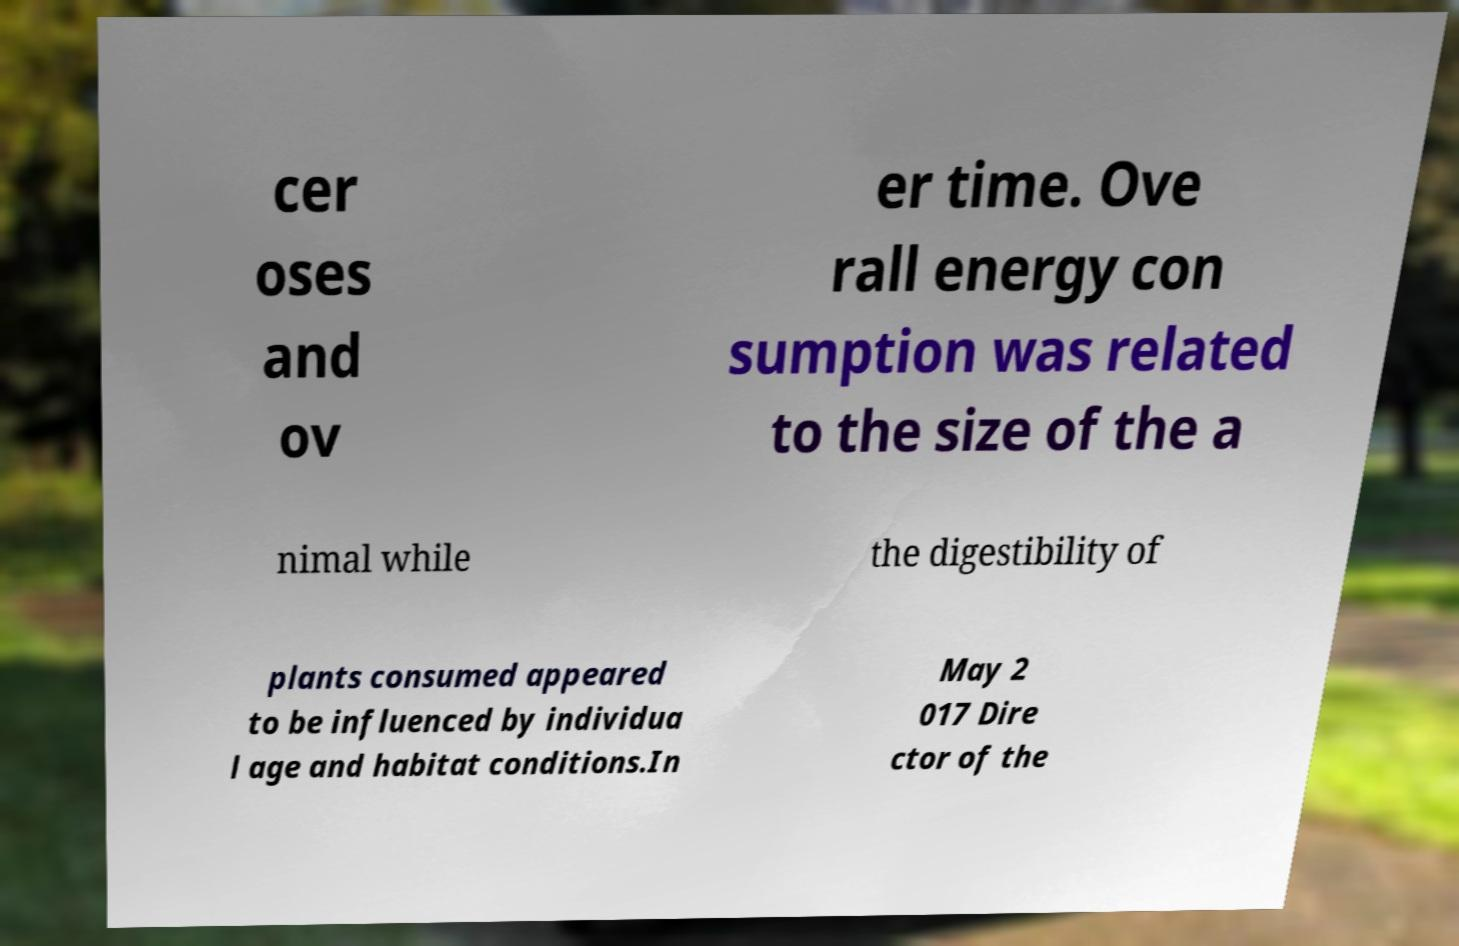Please identify and transcribe the text found in this image. cer oses and ov er time. Ove rall energy con sumption was related to the size of the a nimal while the digestibility of plants consumed appeared to be influenced by individua l age and habitat conditions.In May 2 017 Dire ctor of the 